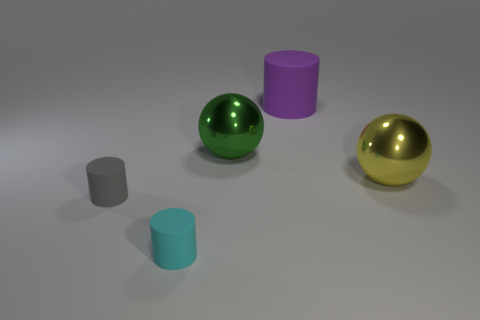Add 4 small cyan rubber objects. How many objects exist? 9 Subtract all spheres. How many objects are left? 3 Subtract 0 gray balls. How many objects are left? 5 Subtract all tiny cyan cylinders. Subtract all gray cylinders. How many objects are left? 3 Add 2 large purple rubber cylinders. How many large purple rubber cylinders are left? 3 Add 5 tiny cyan metallic spheres. How many tiny cyan metallic spheres exist? 5 